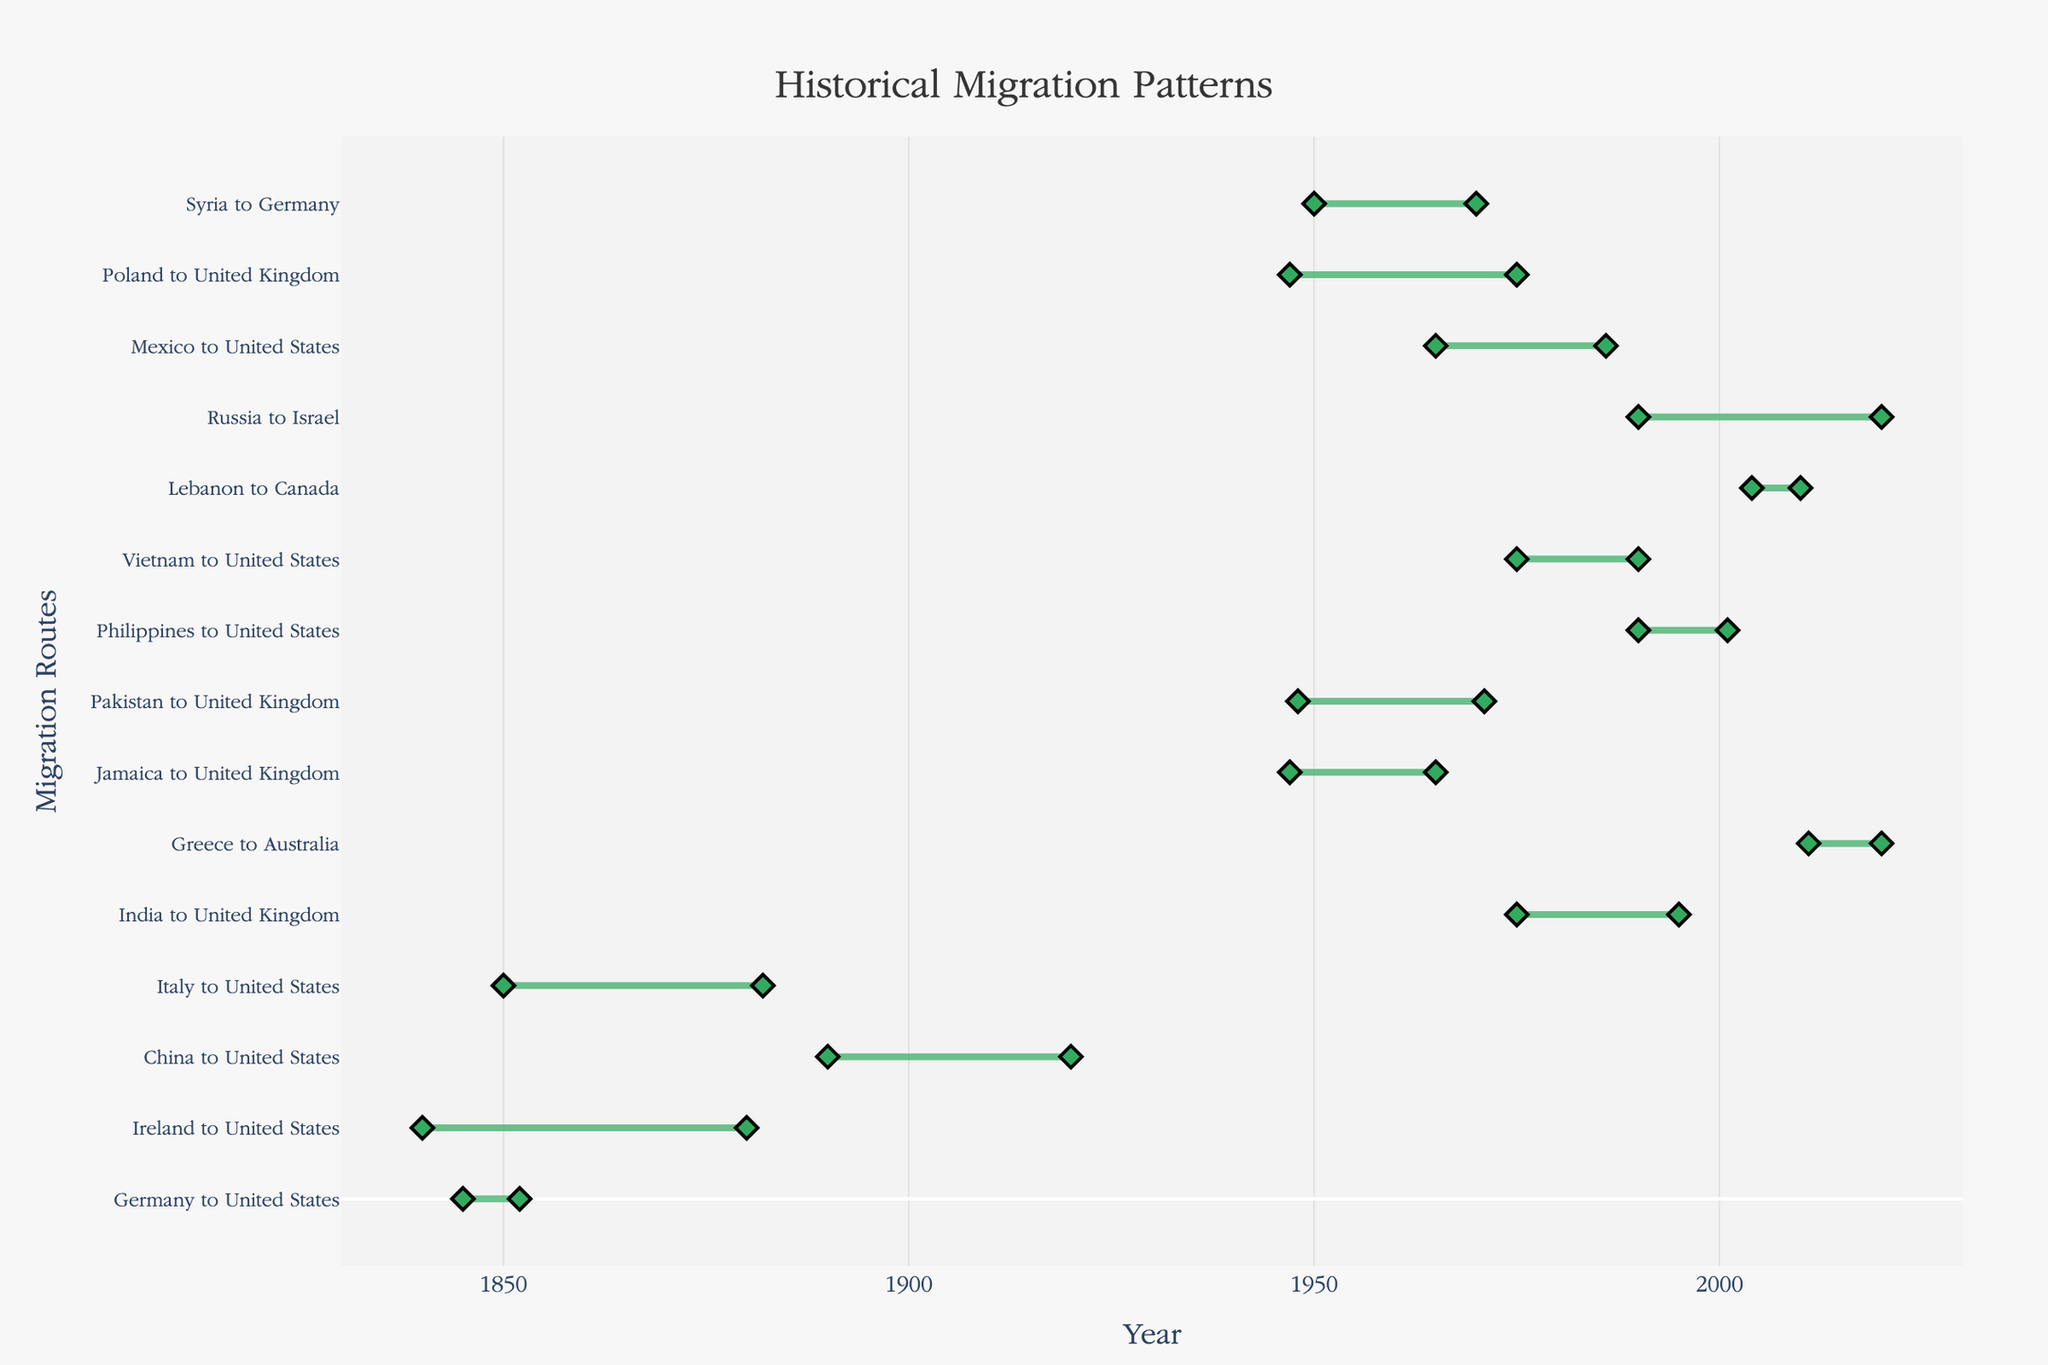How many migration routes are depicted in the figure? To count the total number of migration routes, one can simply count the number of horizontal lines or the number of y-axis tick labels, which represent each migration route.
Answer: 15 Which migration route has the longest duration? To determine the longest duration, subtract the start year from the end year for each migration route and identify the maximum duration. Germany to United States migration spans from 1840 to 1880, which is 40 years.
Answer: Germany to United States Which migration route started earliest? By examining the start years on the x-axis, identify the migration route with the earliest start year. The earliest recorded migration is from Germany to the United States, starting in 1840.
Answer: Germany to United States Which two migration routes to the United States overlap in their timeframes the most? Look for migration routes to the United States and compare their start and end years to identify the overlapping durations. Both the China to United States (1850-1882) and Germany to United States (1840-1880) migration routes have significant overlap (from 1850 to 1880).
Answer: China to United States and Germany to United States What is the range of years depicted on the x-axis? Examine the x-axis range, which indicates the earliest start year to the latest end year shown in the plot. The range expands from 1830 to 2030.
Answer: 1830 to 2030 Which migration route to the United Kingdom had the shortest duration? Find migration routes to the United Kingdom and calculate the duration for each (End Year - Start Year). Poland to United Kingdom (2004-2010) lasted 6 years, which is the shortest duration.
Answer: Poland to United Kingdom How many migration routes ended in 1990 or later? Look at the end years on the x-axis and count how many routes have end years of 1990 or later. There are 6 routes that meet this criterion (Vietnam, United States; Syria, Germany; Mexico, United States; Russia, Israel; Lebanon, Canada; Poland, United Kingdom).
Answer: 6 What is the average duration of migration routes to the United States? Calculate the duration for each migration route to the United States (End Year - Start Year), sum these durations, and then divide by the number of routes to get the average. Durations are (7, 40, 30, 32, 10, 21), so the average is (7 + 40 + 30 + 32 + 10 + 21) / 6 = 23.33 years.
Answer: 23.33 years Which migration route started in 1975? Look at the start years and find the migration route that began in 1975. There are two such routes: Vietnam to United States and Lebanon to Canada.
Answer: Vietnam to United States and Lebanon to Canada 